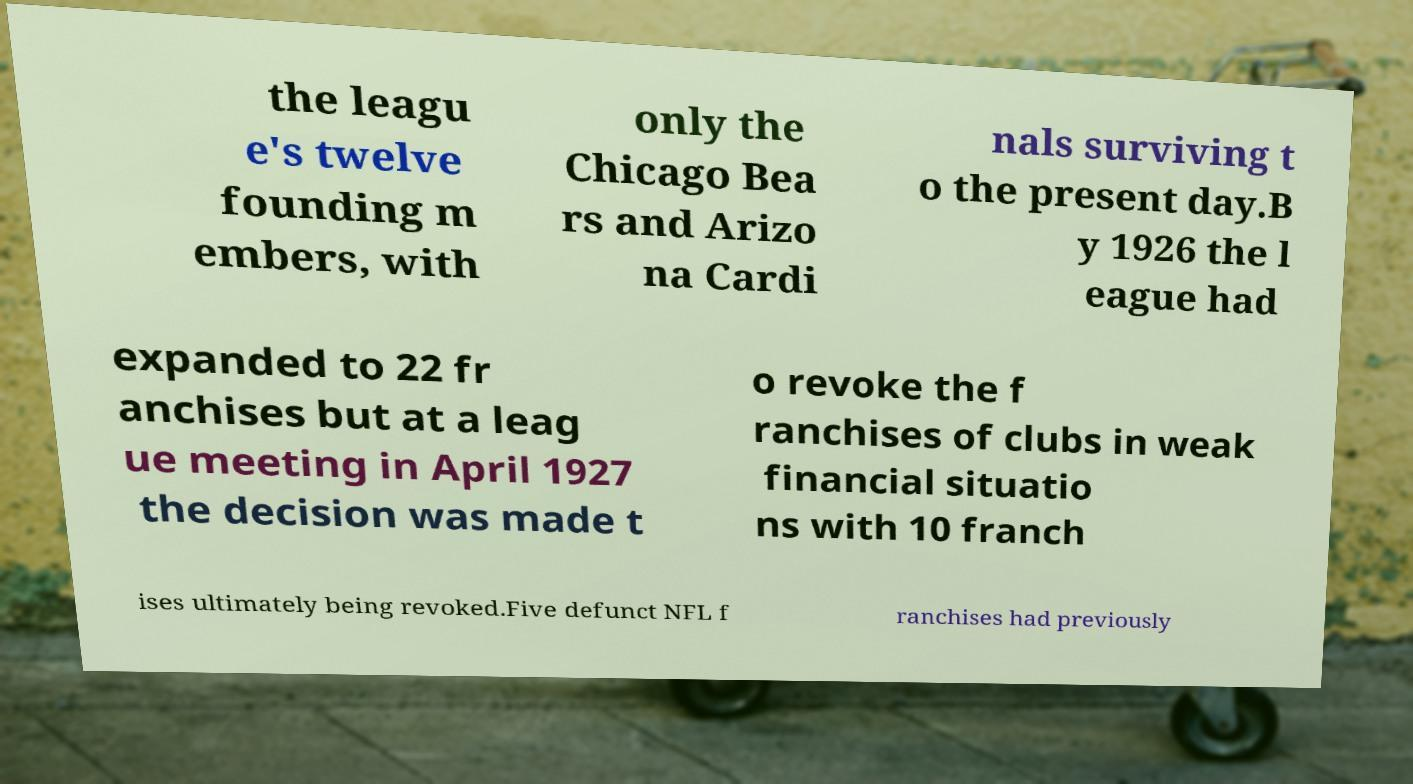Please identify and transcribe the text found in this image. the leagu e's twelve founding m embers, with only the Chicago Bea rs and Arizo na Cardi nals surviving t o the present day.B y 1926 the l eague had expanded to 22 fr anchises but at a leag ue meeting in April 1927 the decision was made t o revoke the f ranchises of clubs in weak financial situatio ns with 10 franch ises ultimately being revoked.Five defunct NFL f ranchises had previously 